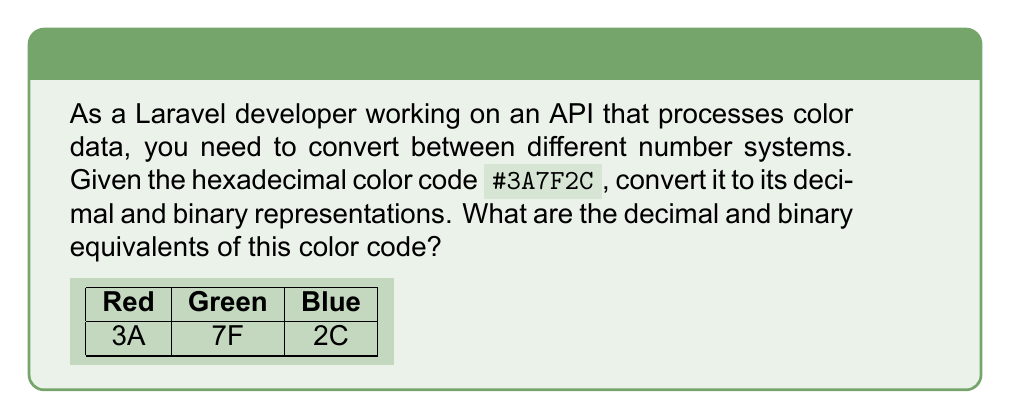Help me with this question. Let's break this down step-by-step:

1) The hexadecimal color code #3A7F2C represents three color components: Red (3A), Green (7F), and Blue (2C).

2) Convert each component from hexadecimal to decimal:

   Red (3A):   
   $3A_{16} = 3 \times 16^1 + 10 \times 16^0 = 48 + 10 = 58_{10}$

   Green (7F):   
   $7F_{16} = 7 \times 16^1 + 15 \times 16^0 = 112 + 15 = 127_{10}$

   Blue (2C):   
   $2C_{16} = 2 \times 16^1 + 12 \times 16^0 = 32 + 12 = 44_{10}$

3) Now, convert each decimal component to binary:

   Red (58):   
   $58_{10} = 00111010_2$

   Green (127):   
   $127_{10} = 01111111_2$

   Blue (44):   
   $44_{10} = 00101100_2$

4) Combine the results:

   Decimal: (58, 127, 44)
   Binary: 00111010 01111111 00101100
Answer: Decimal: (58, 127, 44), Binary: 001110100111111100101100 